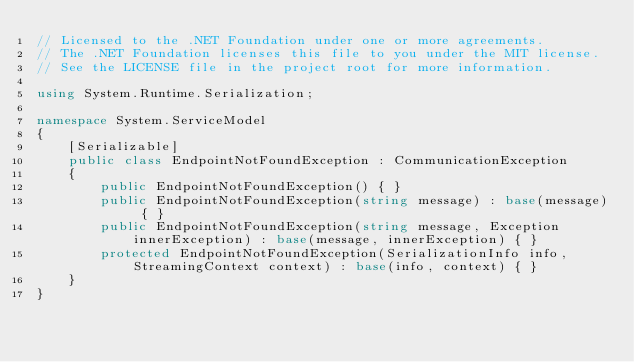<code> <loc_0><loc_0><loc_500><loc_500><_C#_>// Licensed to the .NET Foundation under one or more agreements.
// The .NET Foundation licenses this file to you under the MIT license.
// See the LICENSE file in the project root for more information.

using System.Runtime.Serialization;

namespace System.ServiceModel
{
    [Serializable]
    public class EndpointNotFoundException : CommunicationException
    {
        public EndpointNotFoundException() { }
        public EndpointNotFoundException(string message) : base(message) { }
        public EndpointNotFoundException(string message, Exception innerException) : base(message, innerException) { }
        protected EndpointNotFoundException(SerializationInfo info, StreamingContext context) : base(info, context) { }
    }
}
</code> 